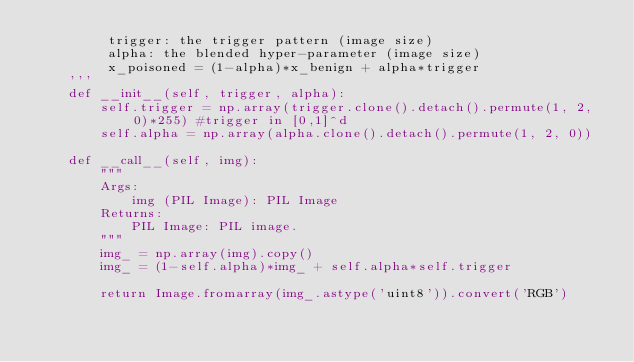<code> <loc_0><loc_0><loc_500><loc_500><_Python_>         trigger: the trigger pattern (image size)
         alpha: the blended hyper-parameter (image size)
         x_poisoned = (1-alpha)*x_benign + alpha*trigger
    '''
    def __init__(self, trigger, alpha):
        self.trigger = np.array(trigger.clone().detach().permute(1, 2, 0)*255) #trigger in [0,1]^d
        self.alpha = np.array(alpha.clone().detach().permute(1, 2, 0))

    def __call__(self, img):
        """
        Args:
            img (PIL Image): PIL Image
        Returns:
            PIL Image: PIL image.
        """
        img_ = np.array(img).copy()
        img_ = (1-self.alpha)*img_ + self.alpha*self.trigger

        return Image.fromarray(img_.astype('uint8')).convert('RGB')

</code> 